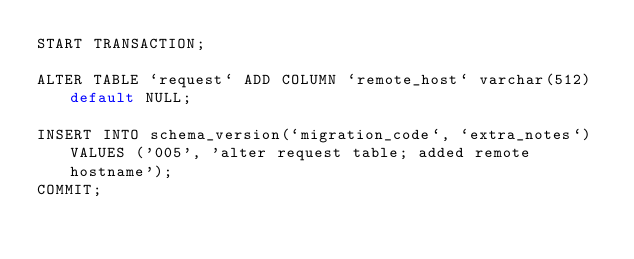<code> <loc_0><loc_0><loc_500><loc_500><_SQL_>START TRANSACTION;

ALTER TABLE `request` ADD COLUMN `remote_host` varchar(512) default NULL;

INSERT INTO schema_version(`migration_code`, `extra_notes`) VALUES ('005', 'alter request table; added remote hostname');
COMMIT;</code> 